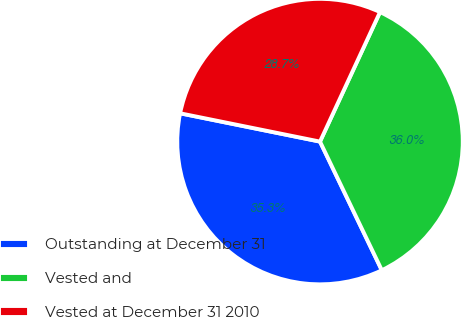Convert chart. <chart><loc_0><loc_0><loc_500><loc_500><pie_chart><fcel>Outstanding at December 31<fcel>Vested and<fcel>Vested at December 31 2010<nl><fcel>35.31%<fcel>35.97%<fcel>28.73%<nl></chart> 